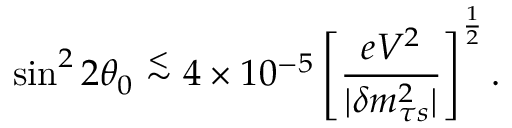Convert formula to latex. <formula><loc_0><loc_0><loc_500><loc_500>\sin ^ { 2 } 2 \theta _ { 0 } \stackrel { < } { \sim } 4 \times 1 0 ^ { - 5 } \left [ { \frac { e V ^ { 2 } } { | \delta m _ { \tau s } ^ { 2 } | } } \right ] ^ { \frac { 1 } { 2 } } .</formula> 